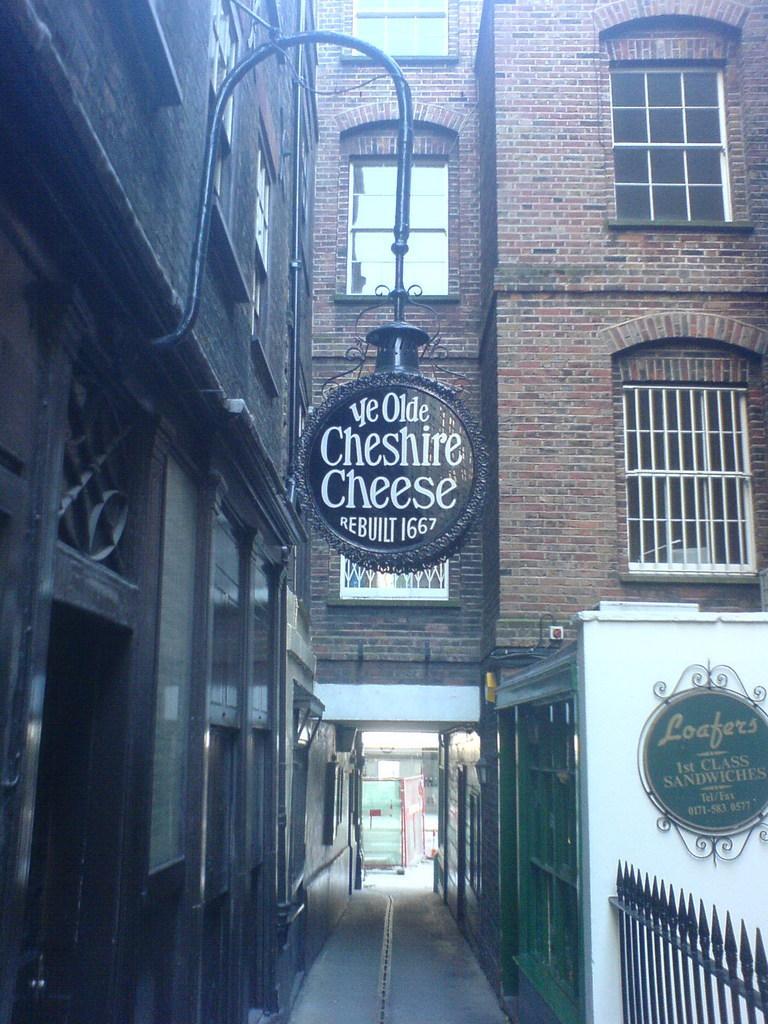In one or two sentences, can you explain what this image depicts? In this image we can see a building. On the building we can see the windows. In the middle we can see a board attached to the building. On the board, we can see some text. On the right side, we can see a board with text. In the bottom right we can see a fencing. 